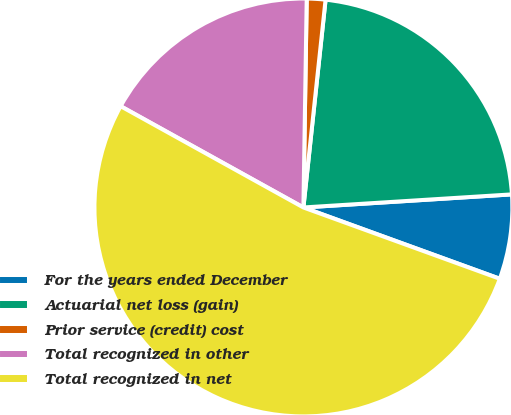Convert chart. <chart><loc_0><loc_0><loc_500><loc_500><pie_chart><fcel>For the years ended December<fcel>Actuarial net loss (gain)<fcel>Prior service (credit) cost<fcel>Total recognized in other<fcel>Total recognized in net<nl><fcel>6.54%<fcel>22.31%<fcel>1.44%<fcel>17.2%<fcel>52.51%<nl></chart> 